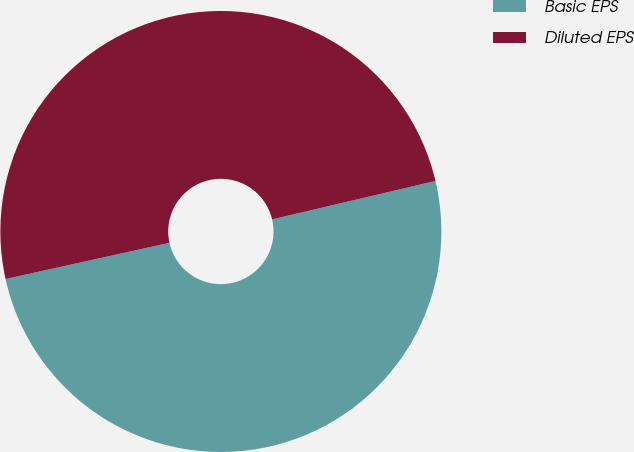<chart> <loc_0><loc_0><loc_500><loc_500><pie_chart><fcel>Basic EPS<fcel>Diluted EPS<nl><fcel>50.22%<fcel>49.78%<nl></chart> 